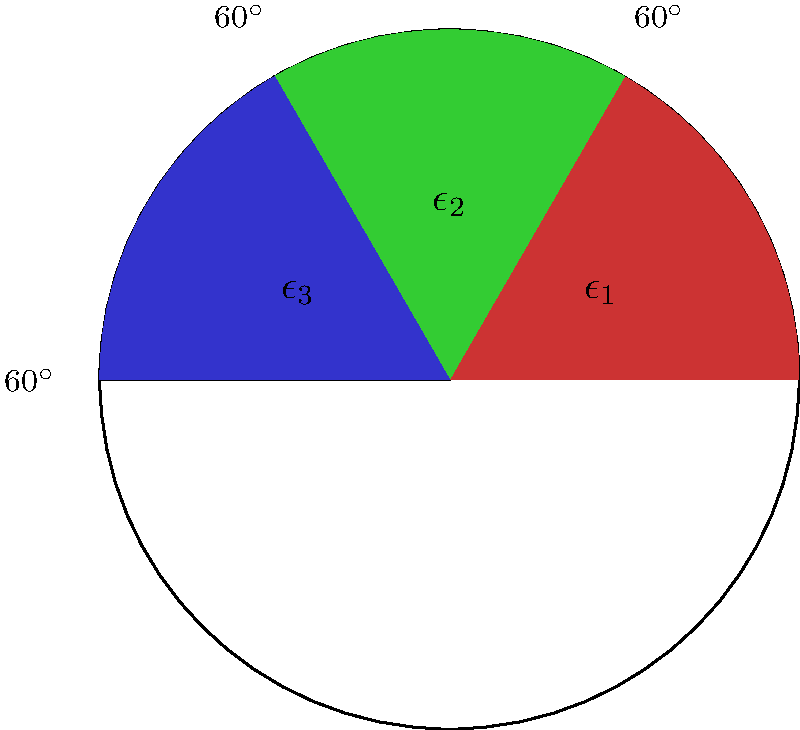In a study of energy dissipation rates in turbulent fluid dynamics, a circular sector model is used to visualize the distribution of energy across different scales. The circle is divided into three equal sectors, each representing a different scale of turbulent eddies. If the total energy dissipation rate is $\epsilon_{total} = 0.9 \text{ m}^2/\text{s}^3$, and the energy dissipation rates for the first two sectors are $\epsilon_1 = 0.3 \text{ m}^2/\text{s}^3$ and $\epsilon_2 = 0.4 \text{ m}^2/\text{s}^3$, what is the energy dissipation rate $\epsilon_3$ for the third sector? To solve this problem, we'll follow these steps:

1) First, recall that in turbulent fluid dynamics, the total energy dissipation rate is the sum of the energy dissipation rates at all scales. In this circular sector model, this means:

   $$\epsilon_{total} = \epsilon_1 + \epsilon_2 + \epsilon_3$$

2) We're given the following values:
   $$\epsilon_{total} = 0.9 \text{ m}^2/\text{s}^3$$
   $$\epsilon_1 = 0.3 \text{ m}^2/\text{s}^3$$
   $$\epsilon_2 = 0.4 \text{ m}^2/\text{s}^3$$

3) To find $\epsilon_3$, we can substitute these values into our equation:

   $$0.9 = 0.3 + 0.4 + \epsilon_3$$

4) Now we can solve for $\epsilon_3$:

   $$\epsilon_3 = 0.9 - 0.3 - 0.4 = 0.2 \text{ m}^2/\text{s}^3$$

5) Therefore, the energy dissipation rate for the third sector is $0.2 \text{ m}^2/\text{s}^3$.

This result is consistent with the conservation of energy in turbulent flows, where the total energy dissipation rate is distributed across different scales of turbulent eddies.
Answer: $0.2 \text{ m}^2/\text{s}^3$ 